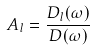<formula> <loc_0><loc_0><loc_500><loc_500>A _ { l } = \frac { D _ { l } ( \omega ) } { D ( \omega ) }</formula> 